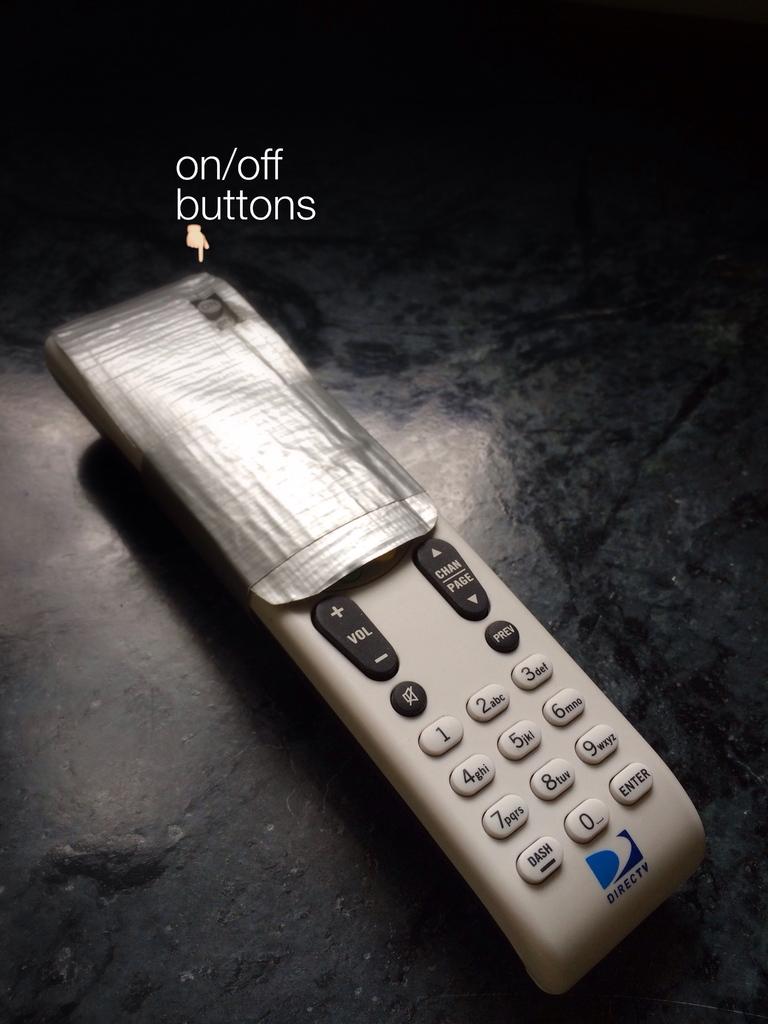What is that top right button on the remote?
Your answer should be very brief. On/off button. 